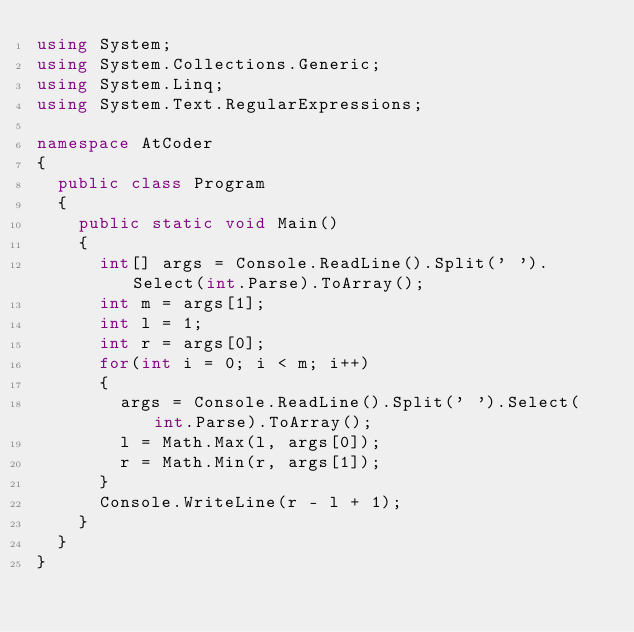Convert code to text. <code><loc_0><loc_0><loc_500><loc_500><_C#_>using System;
using System.Collections.Generic;
using System.Linq;
using System.Text.RegularExpressions;

namespace AtCoder
{
  public class Program
  {
    public static void Main()
    {
      int[] args = Console.ReadLine().Split(' ').Select(int.Parse).ToArray();
      int m = args[1];
      int l = 1;
      int r = args[0];
      for(int i = 0; i < m; i++)
      {
        args = Console.ReadLine().Split(' ').Select(int.Parse).ToArray();
        l = Math.Max(l, args[0]);
        r = Math.Min(r, args[1]);
      }
      Console.WriteLine(r - l + 1);
    }
  }
}
</code> 